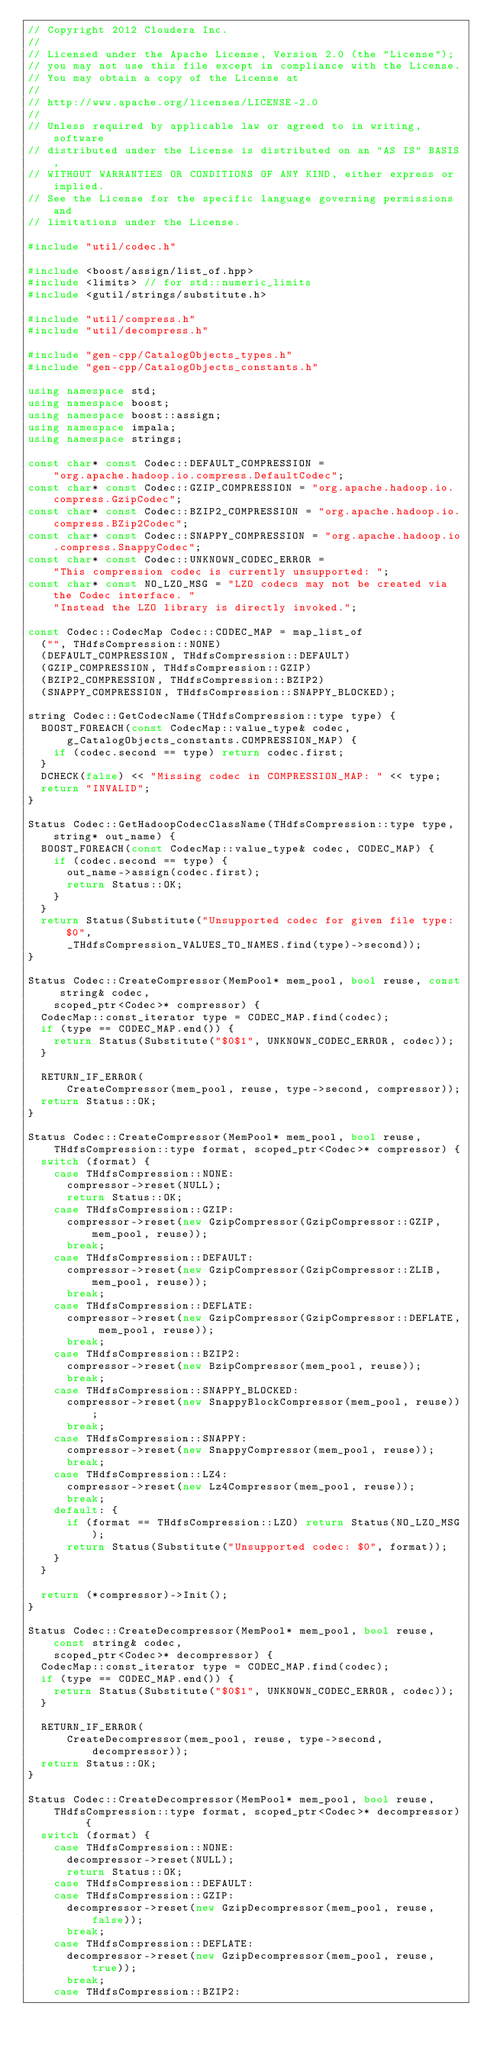Convert code to text. <code><loc_0><loc_0><loc_500><loc_500><_C++_>// Copyright 2012 Cloudera Inc.
//
// Licensed under the Apache License, Version 2.0 (the "License");
// you may not use this file except in compliance with the License.
// You may obtain a copy of the License at
//
// http://www.apache.org/licenses/LICENSE-2.0
//
// Unless required by applicable law or agreed to in writing, software
// distributed under the License is distributed on an "AS IS" BASIS,
// WITHOUT WARRANTIES OR CONDITIONS OF ANY KIND, either express or implied.
// See the License for the specific language governing permissions and
// limitations under the License.

#include "util/codec.h"

#include <boost/assign/list_of.hpp>
#include <limits> // for std::numeric_limits
#include <gutil/strings/substitute.h>

#include "util/compress.h"
#include "util/decompress.h"

#include "gen-cpp/CatalogObjects_types.h"
#include "gen-cpp/CatalogObjects_constants.h"

using namespace std;
using namespace boost;
using namespace boost::assign;
using namespace impala;
using namespace strings;

const char* const Codec::DEFAULT_COMPRESSION =
    "org.apache.hadoop.io.compress.DefaultCodec";
const char* const Codec::GZIP_COMPRESSION = "org.apache.hadoop.io.compress.GzipCodec";
const char* const Codec::BZIP2_COMPRESSION = "org.apache.hadoop.io.compress.BZip2Codec";
const char* const Codec::SNAPPY_COMPRESSION = "org.apache.hadoop.io.compress.SnappyCodec";
const char* const Codec::UNKNOWN_CODEC_ERROR =
    "This compression codec is currently unsupported: ";
const char* const NO_LZO_MSG = "LZO codecs may not be created via the Codec interface. "
    "Instead the LZO library is directly invoked.";

const Codec::CodecMap Codec::CODEC_MAP = map_list_of
  ("", THdfsCompression::NONE)
  (DEFAULT_COMPRESSION, THdfsCompression::DEFAULT)
  (GZIP_COMPRESSION, THdfsCompression::GZIP)
  (BZIP2_COMPRESSION, THdfsCompression::BZIP2)
  (SNAPPY_COMPRESSION, THdfsCompression::SNAPPY_BLOCKED);

string Codec::GetCodecName(THdfsCompression::type type) {
  BOOST_FOREACH(const CodecMap::value_type& codec,
      g_CatalogObjects_constants.COMPRESSION_MAP) {
    if (codec.second == type) return codec.first;
  }
  DCHECK(false) << "Missing codec in COMPRESSION_MAP: " << type;
  return "INVALID";
}

Status Codec::GetHadoopCodecClassName(THdfsCompression::type type, string* out_name) {
  BOOST_FOREACH(const CodecMap::value_type& codec, CODEC_MAP) {
    if (codec.second == type) {
      out_name->assign(codec.first);
      return Status::OK;
    }
  }
  return Status(Substitute("Unsupported codec for given file type: $0",
      _THdfsCompression_VALUES_TO_NAMES.find(type)->second));
}

Status Codec::CreateCompressor(MemPool* mem_pool, bool reuse, const string& codec,
    scoped_ptr<Codec>* compressor) {
  CodecMap::const_iterator type = CODEC_MAP.find(codec);
  if (type == CODEC_MAP.end()) {
    return Status(Substitute("$0$1", UNKNOWN_CODEC_ERROR, codec));
  }

  RETURN_IF_ERROR(
      CreateCompressor(mem_pool, reuse, type->second, compressor));
  return Status::OK;
}

Status Codec::CreateCompressor(MemPool* mem_pool, bool reuse,
    THdfsCompression::type format, scoped_ptr<Codec>* compressor) {
  switch (format) {
    case THdfsCompression::NONE:
      compressor->reset(NULL);
      return Status::OK;
    case THdfsCompression::GZIP:
      compressor->reset(new GzipCompressor(GzipCompressor::GZIP, mem_pool, reuse));
      break;
    case THdfsCompression::DEFAULT:
      compressor->reset(new GzipCompressor(GzipCompressor::ZLIB, mem_pool, reuse));
      break;
    case THdfsCompression::DEFLATE:
      compressor->reset(new GzipCompressor(GzipCompressor::DEFLATE, mem_pool, reuse));
      break;
    case THdfsCompression::BZIP2:
      compressor->reset(new BzipCompressor(mem_pool, reuse));
      break;
    case THdfsCompression::SNAPPY_BLOCKED:
      compressor->reset(new SnappyBlockCompressor(mem_pool, reuse));
      break;
    case THdfsCompression::SNAPPY:
      compressor->reset(new SnappyCompressor(mem_pool, reuse));
      break;
    case THdfsCompression::LZ4:
      compressor->reset(new Lz4Compressor(mem_pool, reuse));
      break;
    default: {
      if (format == THdfsCompression::LZO) return Status(NO_LZO_MSG);
      return Status(Substitute("Unsupported codec: $0", format));
    }
  }

  return (*compressor)->Init();
}

Status Codec::CreateDecompressor(MemPool* mem_pool, bool reuse, const string& codec,
    scoped_ptr<Codec>* decompressor) {
  CodecMap::const_iterator type = CODEC_MAP.find(codec);
  if (type == CODEC_MAP.end()) {
    return Status(Substitute("$0$1", UNKNOWN_CODEC_ERROR, codec));
  }

  RETURN_IF_ERROR(
      CreateDecompressor(mem_pool, reuse, type->second, decompressor));
  return Status::OK;
}

Status Codec::CreateDecompressor(MemPool* mem_pool, bool reuse,
    THdfsCompression::type format, scoped_ptr<Codec>* decompressor) {
  switch (format) {
    case THdfsCompression::NONE:
      decompressor->reset(NULL);
      return Status::OK;
    case THdfsCompression::DEFAULT:
    case THdfsCompression::GZIP:
      decompressor->reset(new GzipDecompressor(mem_pool, reuse, false));
      break;
    case THdfsCompression::DEFLATE:
      decompressor->reset(new GzipDecompressor(mem_pool, reuse, true));
      break;
    case THdfsCompression::BZIP2:</code> 